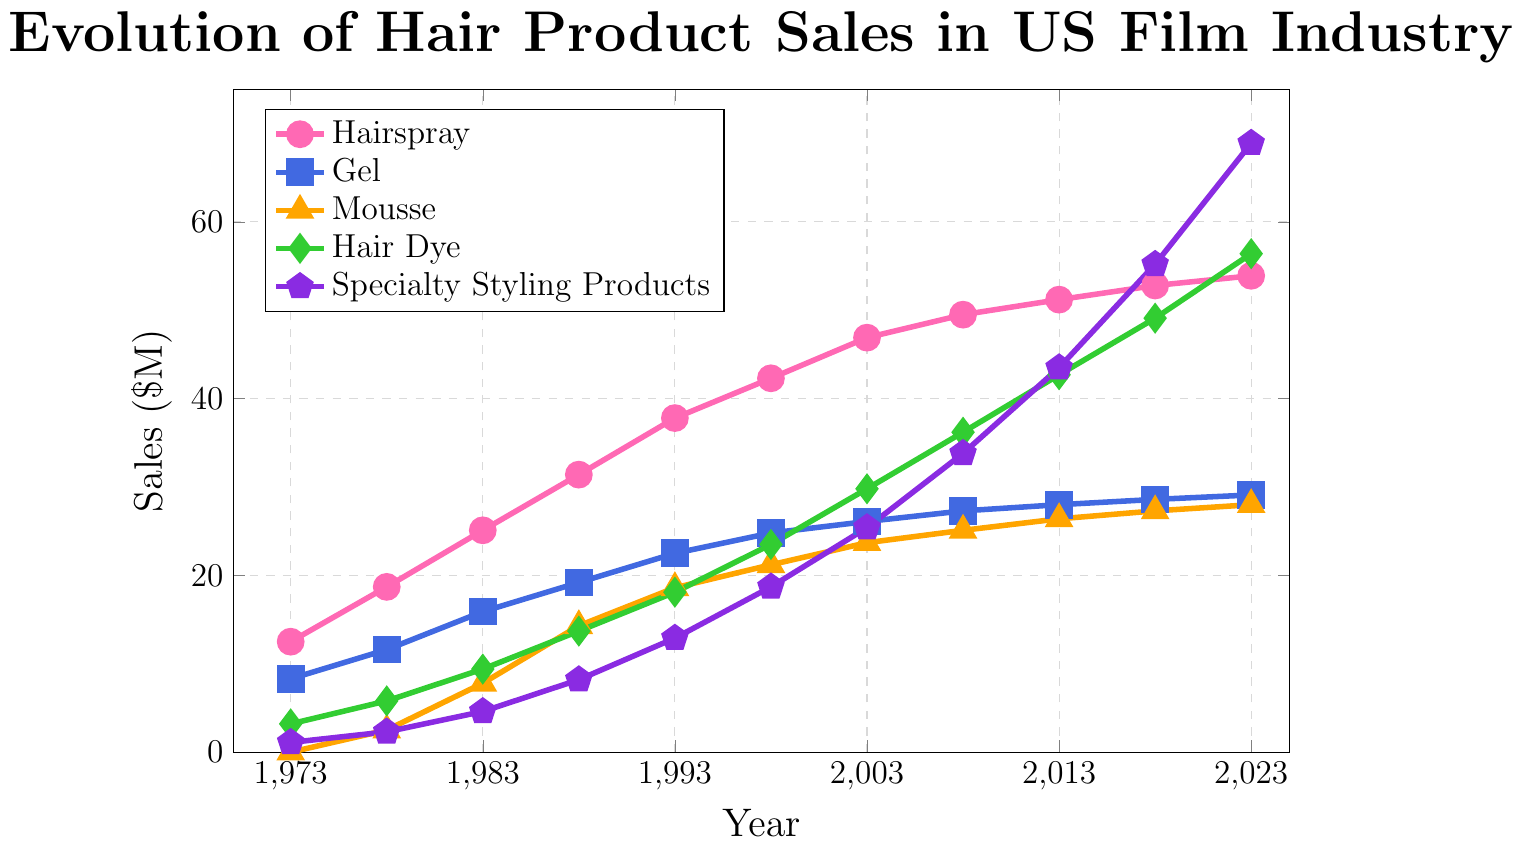What year did hairspray sales first surpass $20 million? To find the year hairspray sales first surpassed $20 million, look at the plot for the pink line and find the first point where the y-axis value is greater than $20 million. In the plot, this occurs at the year 1983 with sales of $25.1 million.
Answer: 1983 Between 1973 and 2023, which hair product saw the largest increase in sales? Check the difference in sales for each product between 1973 and 2023. Hairspray: $53.9M - $12.5M = $41.4M, Gel: $29.1M - $8.3M = $20.8M, Mousse: $28.0M - $0M = $28.0M, Hair Dye: $56.4M - $3.2M = $53.2M, Specialty Styling Products: $68.9M - $1.1M = $67.8M. The largest increase is for Specialty Styling Products at $67.8 million.
Answer: Specialty Styling Products How much more did hair dye sales grow compared to gel sales between 1973 and 2023? First, calculate the growth for each product: Gel: $29.1M - $8.3M = $20.8M, Hair Dye: $56.4M - $3.2M = $53.2M. Then find the difference: $53.2M - $20.8M = $32.4M.
Answer: $32.4 million By what percent did mousse sales increase from 1978 to 1983? Find mousse sales for 1978 and 1983: $2.5M and $7.8M respectively. Increase: $7.8M - $2.5M = $5.3M. Percent increase: ($5.3M / $2.5M) * 100% = 212%.
Answer: 212% In what year did specialty styling products sales surpass hair dye sales? Compare points where the purple line (specialty styling products) exceeds the green line (hair dye). This first happens in 2018, with sales of $55.2M for specialty styling products compared to $49.1M for hair dye.
Answer: 2018 